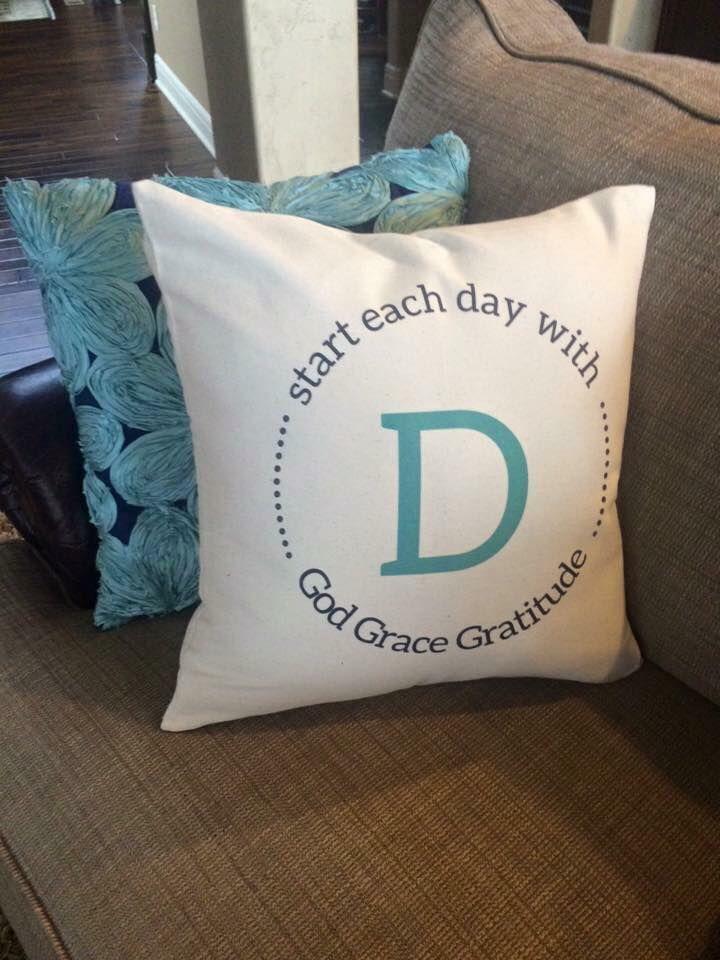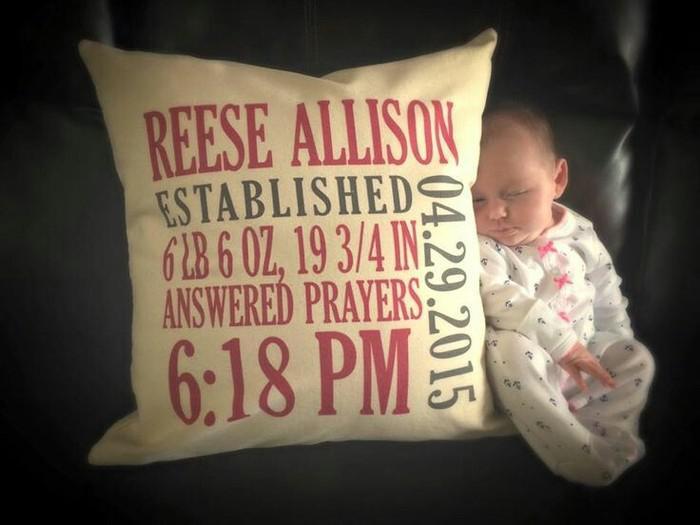The first image is the image on the left, the second image is the image on the right. Evaluate the accuracy of this statement regarding the images: "The large squarish item in the foreground of one image is stamped at the center with a single alphabet letter.". Is it true? Answer yes or no. Yes. The first image is the image on the left, the second image is the image on the right. Considering the images on both sides, is "There are an even number of pillows and no people." valid? Answer yes or no. No. 